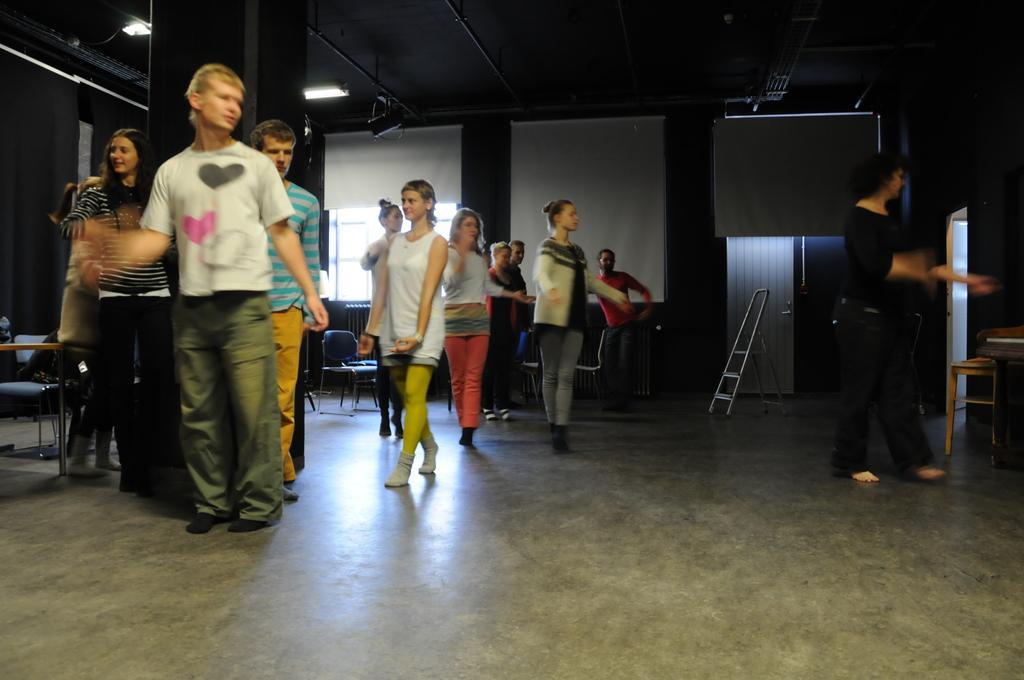Describe this image in one or two sentences. On the left side,there are persons dancing on the floor and there are persons dancing. On the right side, there is a person on the floor. In the background, there are windows covered with white color curtains and there are chairs. 